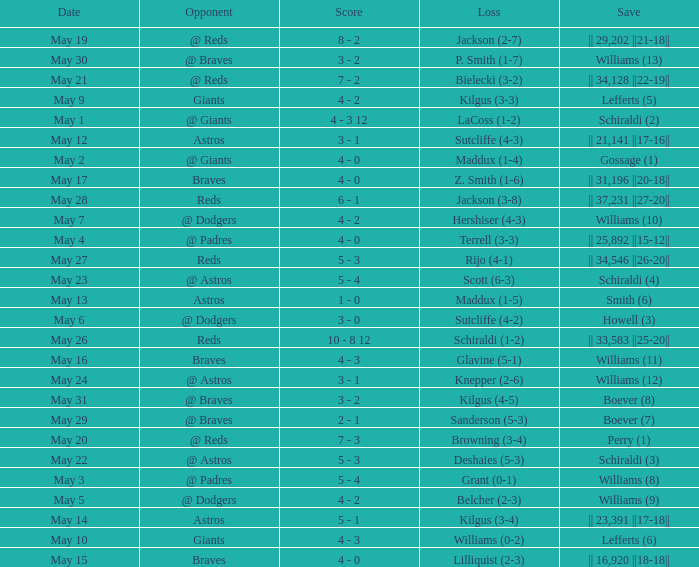Name the opponent for save of williams (9) @ Dodgers. 